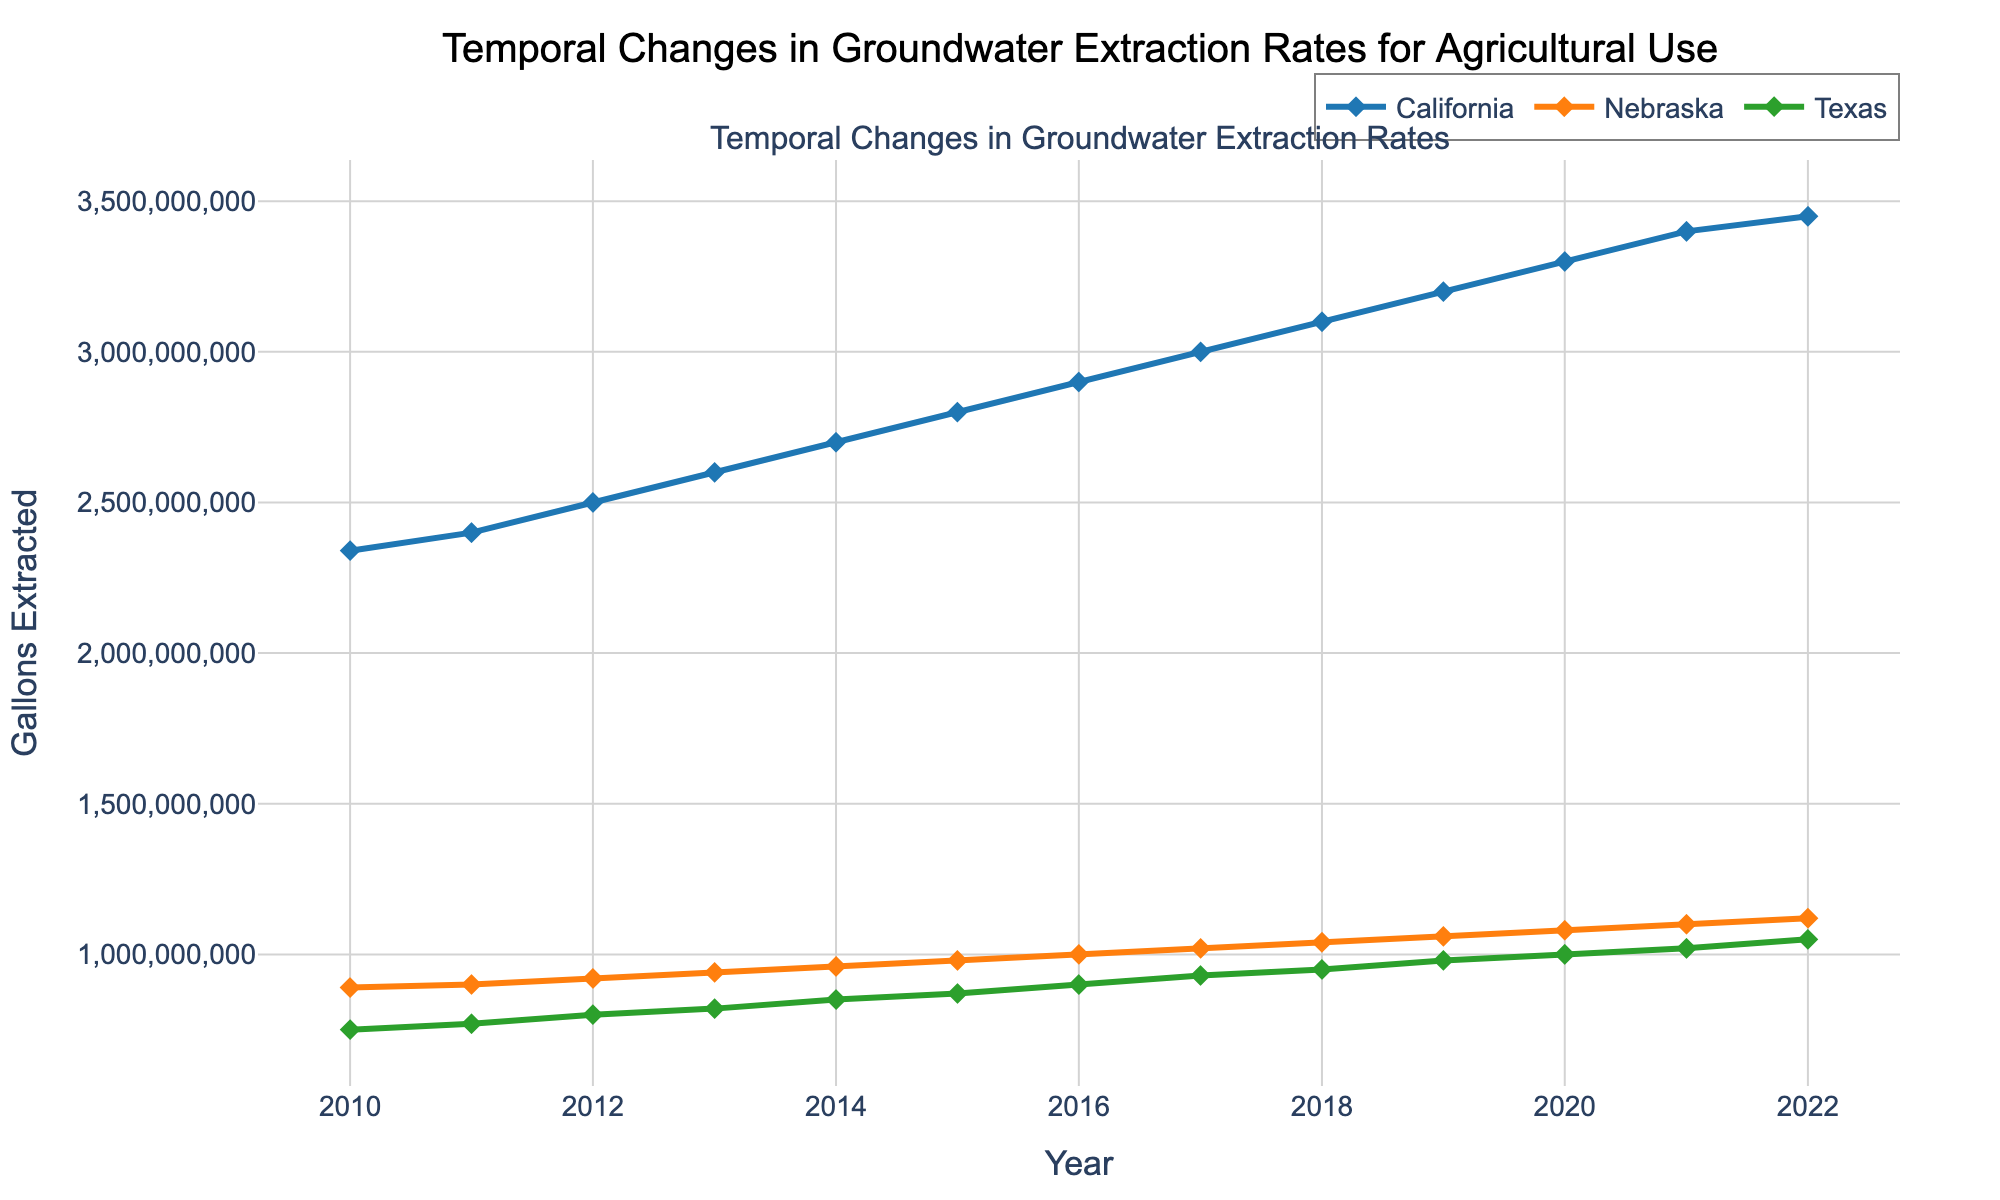What is the title of the plot? The title of the plot is usually placed at the top. In this case, it is clear since it’s annotated with large font, centrally aligned, and reads "Temporal Changes in Groundwater Extraction Rates for Agricultural Use".
Answer: Temporal Changes in Groundwater Extraction Rates for Agricultural Use What are the units of measurement on the y-axis? The y-axis typically represents the quantity being measured. Here, it's labeled "Gallons Extracted", indicating the unit of measurement.
Answer: Gallons Extracted How many regions are represented in the plot? Each region is represented by a distinct color and marker in the plot. Upon observing, there are three lines/markers denoting three regions.
Answer: Three Which region had the highest groundwater extraction rate in 2022? The y-values at the point corresponding to 2022 need to be checked for each region's line. The highest y-value for 2022 is represented by the "California" line.
Answer: California What is the trend in groundwater extraction for Nebraska from 2010 to 2022? Observing the Nebraska line, it starts at a lower value in 2010 and increases steadily through to 2022.
Answer: Increasing When did Texas reach 1 billion gallons of groundwater extracted? By tracing the Texas line and noting the x-values when y-value reaches 1 billion gallons, it can be seen at the point for the year 2020.
Answer: 2020 What is the difference in groundwater extraction between California and Texas in 2022? Extract the y-values for California and Texas in 2022, which are 3,450,000,000 and 1,050,000,000 gallons respectively. Compute the difference: 3,450,000,000 - 1,050,000,000 = 2,400,000,000 gallons.
Answer: 2,400,000,000 By how much did Nebraska's extraction rate increase from 2010 to 2022? The y-values for Nebraska in 2010 and 2022 are 890,000,000 and 1,120,000,000 gallons respectively. The increase is 1,120,000,000 - 890,000,000 = 230,000,000 gallons.
Answer: 230,000,000 What is the average annual groundwater extraction for California over the period shown? Sum the gallons extracted for California across all years and divide by the number of years (13): (2340 + 2400 + 2500 + ... + 3450) million gallons. The total is 439,000,000 gallons, and the average is 439,000,000 / 13 ≈ 33,769,231 gallons.
Answer: 33,769,231 gallons 